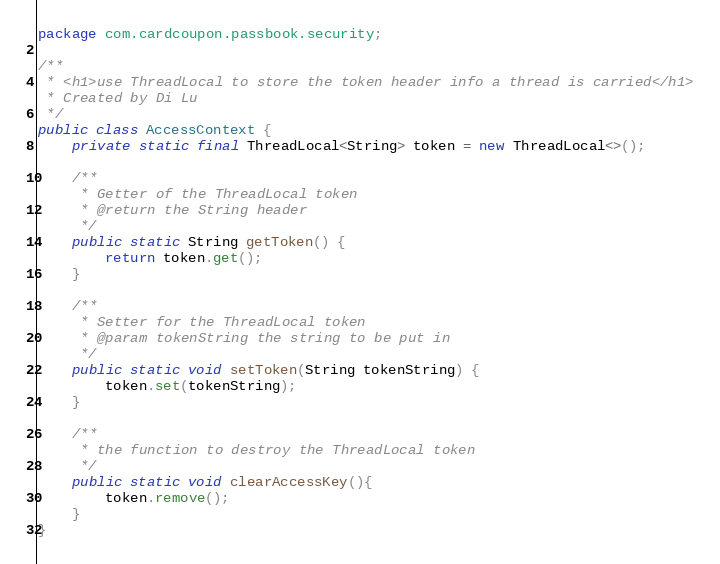Convert code to text. <code><loc_0><loc_0><loc_500><loc_500><_Java_>package com.cardcoupon.passbook.security;

/**
 * <h1>use ThreadLocal to store the token header info a thread is carried</h1>
 * Created by Di Lu
 */
public class AccessContext {
    private static final ThreadLocal<String> token = new ThreadLocal<>();

    /**
     * Getter of the ThreadLocal token
     * @return the String header
     */
    public static String getToken() {
        return token.get();
    }

    /**
     * Setter for the ThreadLocal token
     * @param tokenString the string to be put in
     */
    public static void setToken(String tokenString) {
        token.set(tokenString);
    }

    /**
     * the function to destroy the ThreadLocal token
     */
    public static void clearAccessKey(){
        token.remove();
    }
}
</code> 